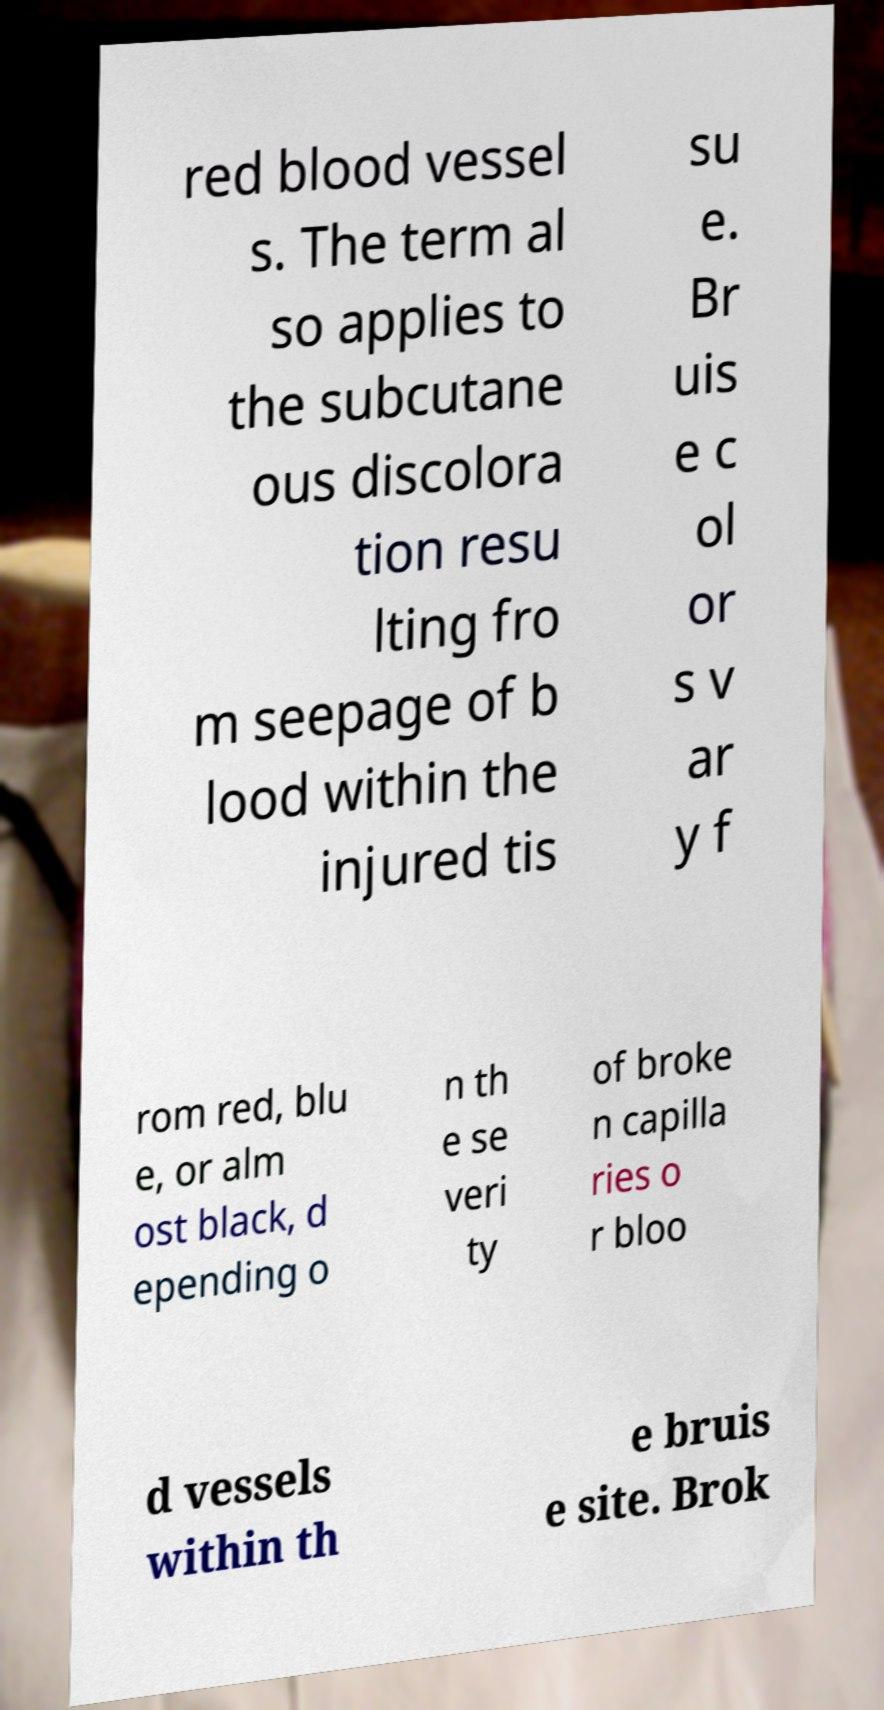Can you read and provide the text displayed in the image?This photo seems to have some interesting text. Can you extract and type it out for me? red blood vessel s. The term al so applies to the subcutane ous discolora tion resu lting fro m seepage of b lood within the injured tis su e. Br uis e c ol or s v ar y f rom red, blu e, or alm ost black, d epending o n th e se veri ty of broke n capilla ries o r bloo d vessels within th e bruis e site. Brok 